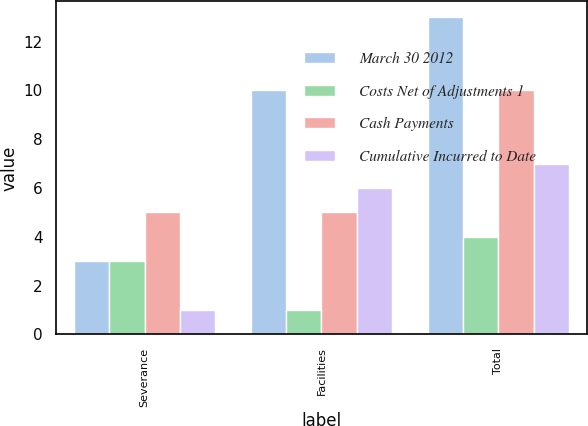<chart> <loc_0><loc_0><loc_500><loc_500><stacked_bar_chart><ecel><fcel>Severance<fcel>Facilities<fcel>Total<nl><fcel>March 30 2012<fcel>3<fcel>10<fcel>13<nl><fcel>Costs Net of Adjustments 1<fcel>3<fcel>1<fcel>4<nl><fcel>Cash Payments<fcel>5<fcel>5<fcel>10<nl><fcel>Cumulative Incurred to Date<fcel>1<fcel>6<fcel>7<nl></chart> 